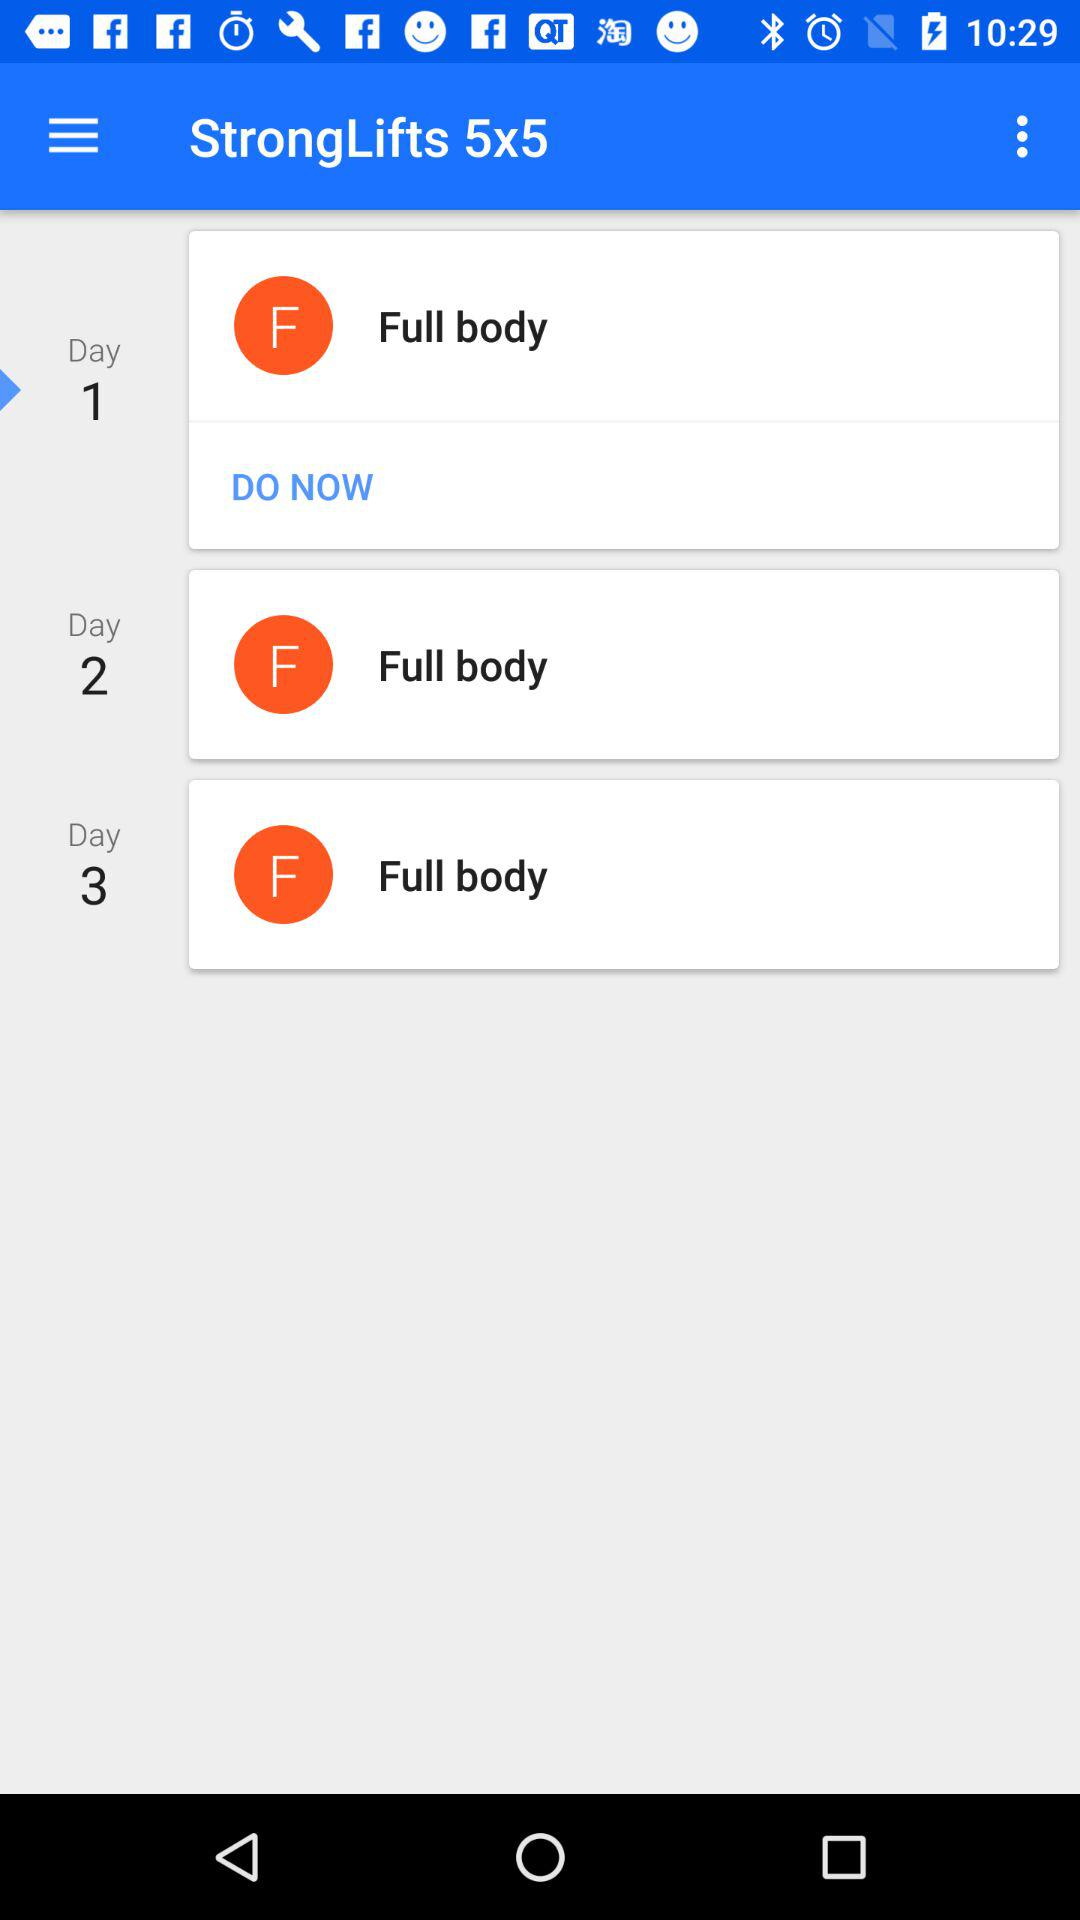What is the name of the workout? The name of the workout is "StrongLifts 5x5". 